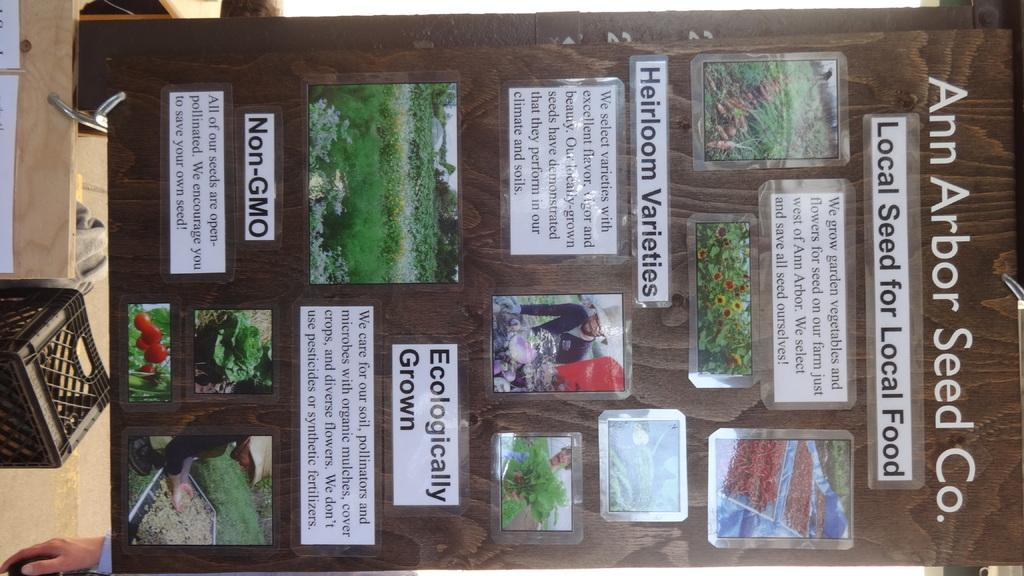Provide a one-sentence caption for the provided image. A board with information about the Ann Arbor Seed company has some information about heirloom varieties. 